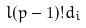<formula> <loc_0><loc_0><loc_500><loc_500>l ( p - 1 ) ! d _ { i }</formula> 